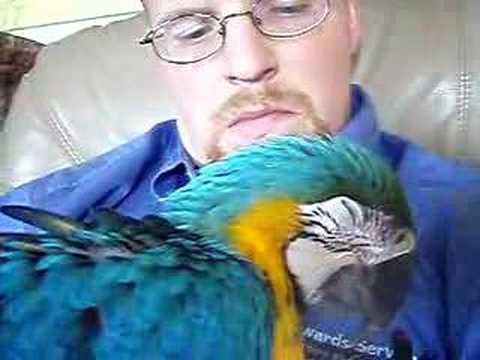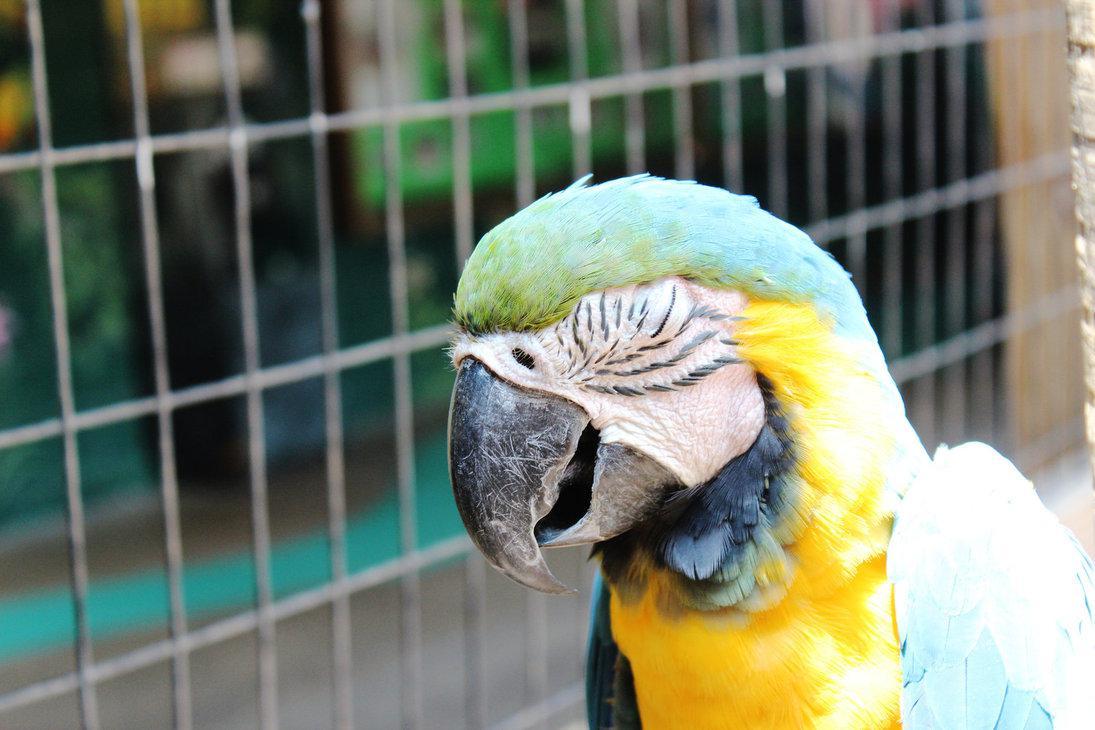The first image is the image on the left, the second image is the image on the right. For the images displayed, is the sentence "All of the birds are outside." factually correct? Answer yes or no. No. The first image is the image on the left, the second image is the image on the right. Assess this claim about the two images: "Each image contains a single parrot, and each parrot has its eye squeezed tightly shut.". Correct or not? Answer yes or no. Yes. 